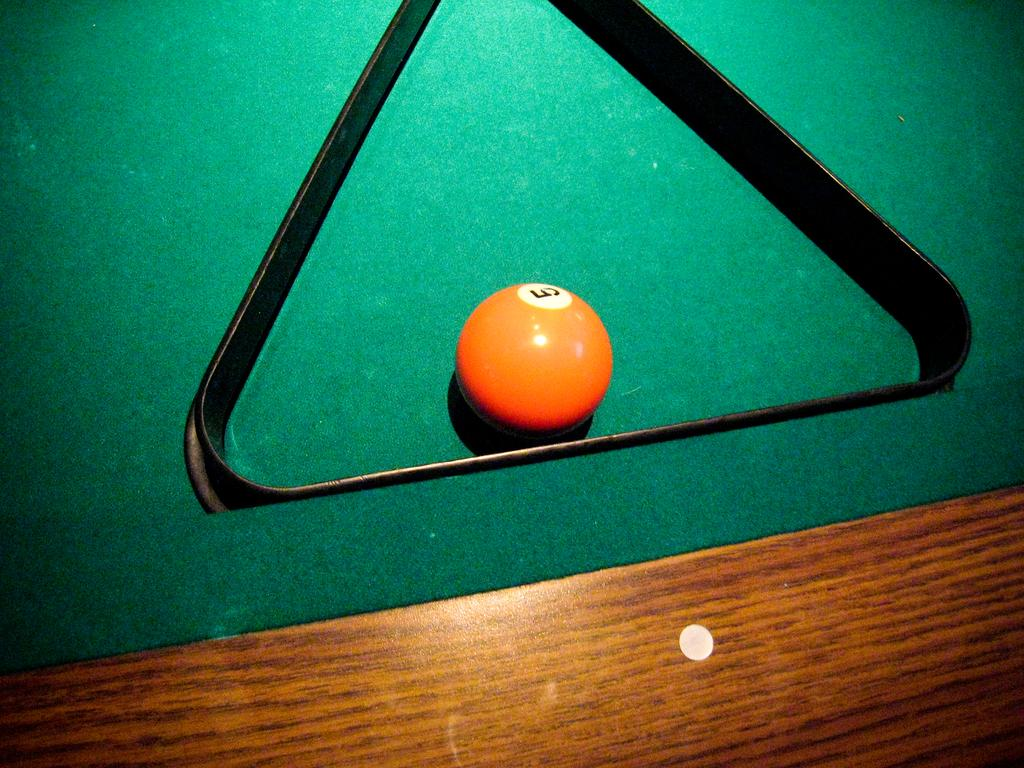What is the main object in the image? There is a ball in the image. Can you describe any other objects in the image? There is another object in the image, but its specific details are not mentioned. What color is the surface in the image? The green surface is present in the image. What type of wren can be seen sitting on the sheet in the image? There is no wren or sheet present in the image; it only features a ball and an unspecified object on a green surface. 